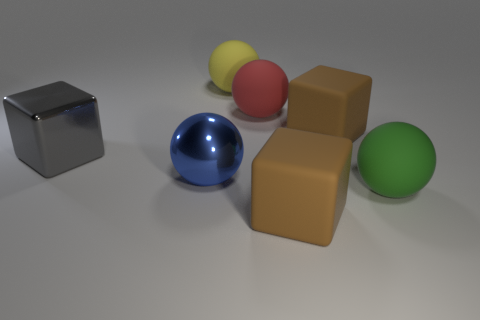Do the shiny object that is left of the blue thing and the yellow object have the same shape? The shiny object to the left of the blue sphere and the yellow sphere do not share the same shape. The shiny object is a cube with six equal square faces, whereas the yellow object is a sphere with a uniform curved surface. 